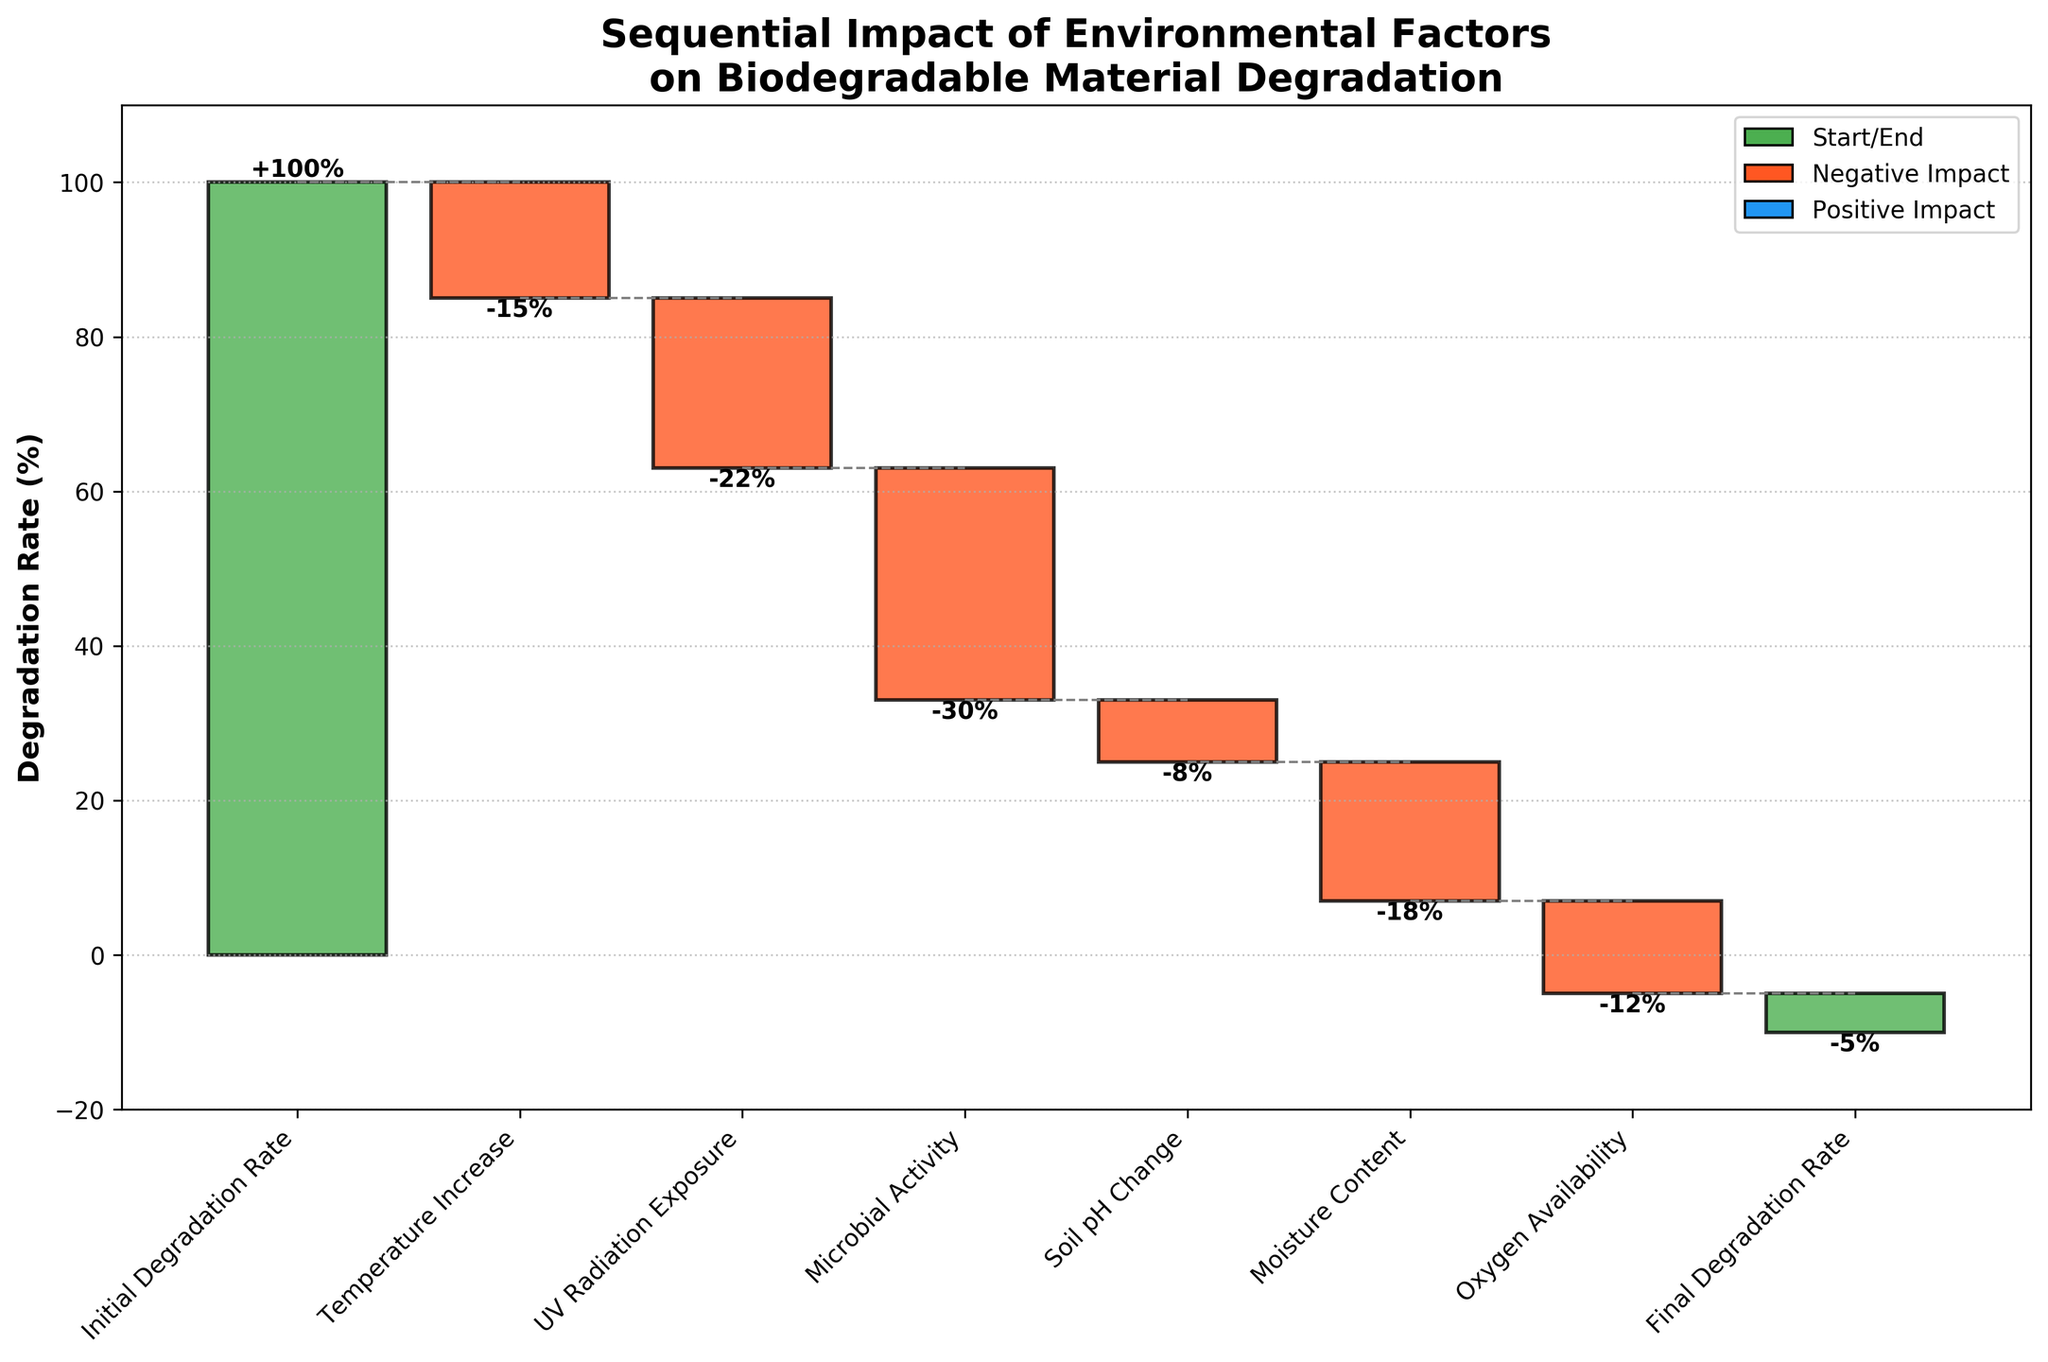What is the initial degradation rate indicated in the chart? The initial degradation rate is indicated by the first green bar labeled "Initial Degradation Rate".
Answer: 100% By how much does UV radiation exposure affect the degradation rate? The bar labeled "UV Radiation Exposure" is red and has a value of -22%, indicating a reduction in the degradation rate.
Answer: -22% How many environmental factors are analyzed in the chart (excluding the initial and final degradation rates)? There are six environmental factors in between the initial and final degradation rates labeled on the x-axis.
Answer: 6 What is the final degradation rate after accounting for all environmental factors? The final degradation rate is indicated by the last green bar labeled "Final Degradation Rate".
Answer: -5% What is the combined impact of Temperature Increase and Soil pH Change on the degradation rate? The impact of Temperature Increase is -15%, and the impact of Soil pH Change is -8%. Adding these values: -15 + (-8) = -23%.
Answer: -23% Which factor has the largest negative impact on the degradation rate? The bar with the largest negative value is labeled "Microbial Activity" with an impact of -30%.
Answer: Microbial Activity What is the overall impact of all the environmental factors considered in the chart? Add the impact of all the factors: -15 (Temperature Increase) + (-22) (UV Radiation Exposure) + (-30) (Microbial Activity) + (-8) (Soil pH Change) + (-18) (Moisture Content) + (-12) (Oxygen Availability) = -105%. The final degradation rate is lower by 105% from the initial rate.
Answer: -105% Is the effect of Moisture Content greater or smaller than the effect of Oxygen Availability? The impact of Moisture Content is -18%, and the impact of Oxygen Availability is -12%. Since -18% is more negative than -12%, the effect is greater.
Answer: Greater Considering all factors, does any factor have a positive impact on the degradation rate? Since all bars, except the initial and final degradation rates, are red (negative impact), none of the environmental factors have a positive impact.
Answer: No 